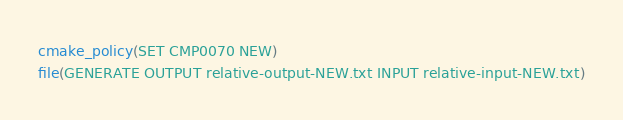Convert code to text. <code><loc_0><loc_0><loc_500><loc_500><_CMake_>cmake_policy(SET CMP0070 NEW)
file(GENERATE OUTPUT relative-output-NEW.txt INPUT relative-input-NEW.txt)
</code> 